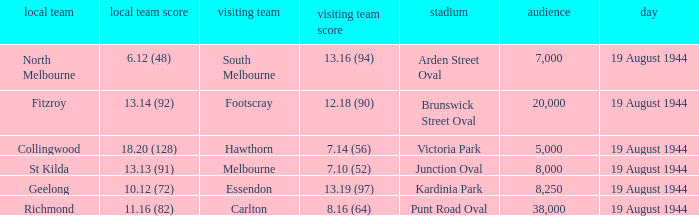What is Fitzroy's Home team Crowd? 20000.0. 